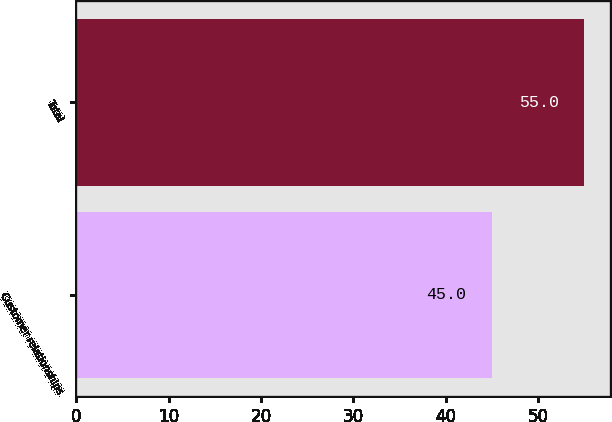<chart> <loc_0><loc_0><loc_500><loc_500><bar_chart><fcel>Customer relationships<fcel>Total<nl><fcel>45<fcel>55<nl></chart> 